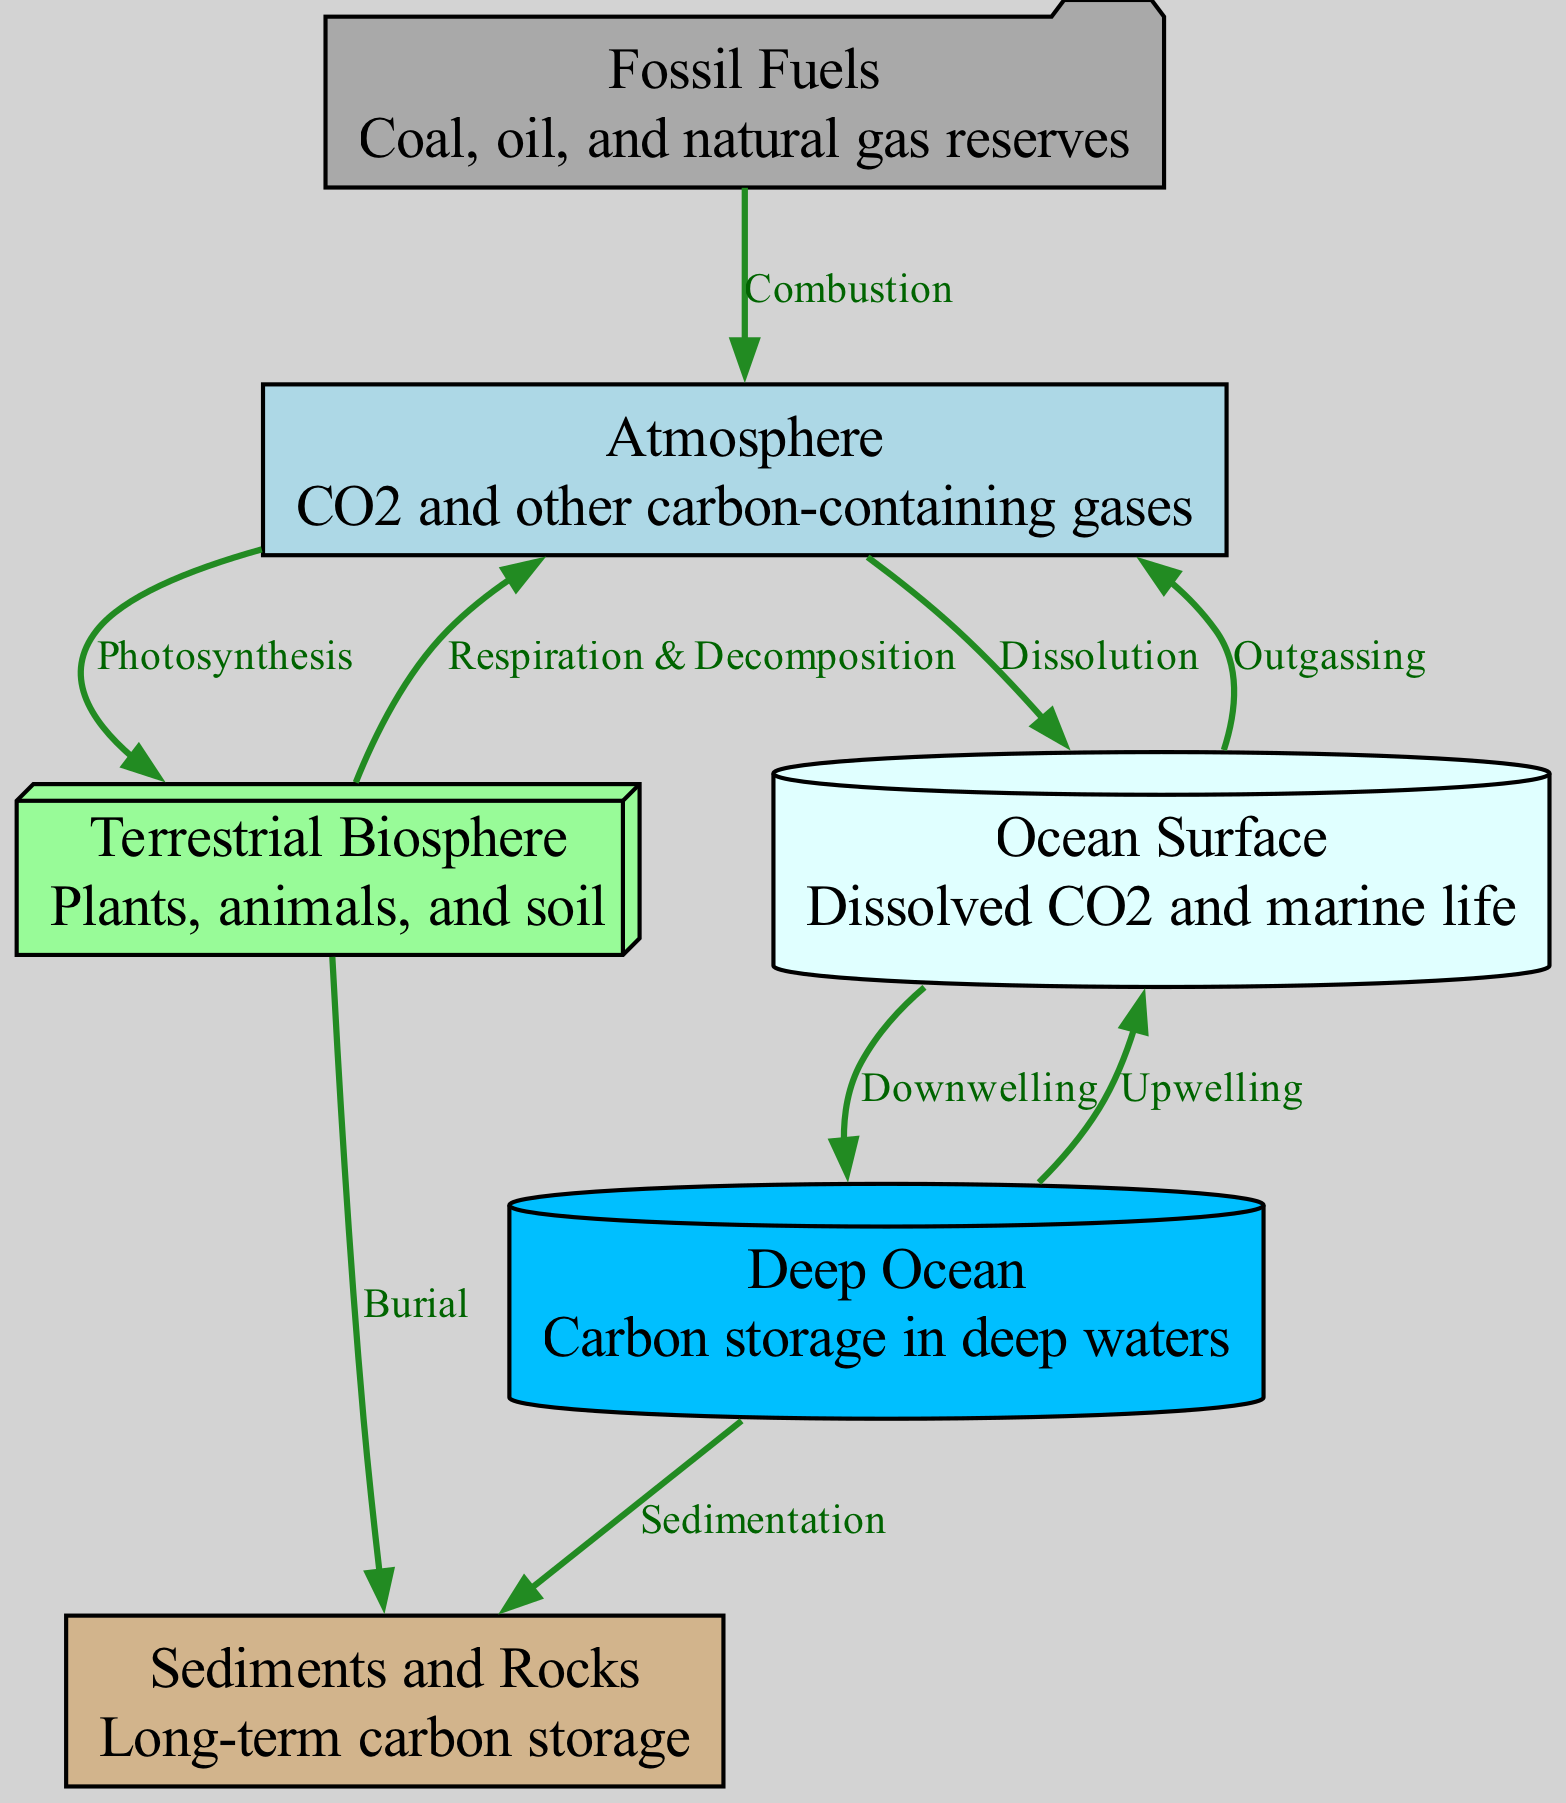What are the components of the carbon cycle illustrated in the diagram? The diagram includes six components: Atmosphere, Terrestrial Biosphere, Ocean Surface, Deep Ocean, Fossil Fuels, and Sediments. These are represented as nodes in the diagram that illustrate where carbon can exist within the cycle.
Answer: Atmosphere, Terrestrial Biosphere, Ocean Surface, Deep Ocean, Fossil Fuels, Sediments How many nodes are present in the diagram? By counting the six distinct nodes represented in the diagram, we can determine that there are a total of six nodes present which correspond to the different components of the carbon cycle.
Answer: 6 What process connects the atmosphere to the terrestrial biosphere? The relevant edge marked "Photosynthesis" indicates the process by which carbon dioxide is absorbed by plants from the atmosphere and used for photosynthesis, thus creating a direct connection between these two nodes.
Answer: Photosynthesis Which node is involved in both respiration and decomposition? The Terrestrial Biosphere node is associated with both processes. The edge labeled "Respiration & Decomposition" connects it back to the atmosphere, highlighting how organisms release carbon through these biological processes.
Answer: Terrestrial Biosphere What connection is established between the ocean surface and the atmosphere? There are two significant edges labeled "Dissolution" and "Outgassing," indicating that carbon is transferred to the ocean surface from the atmosphere via dissolution and returned to the atmosphere from the ocean surface via outgassing.
Answer: Dissolution and Outgassing Which node represents long-term carbon storage? The Sediments and Rocks node is specifically identified for long-term carbon storage. This node emphasizes the geological processes where carbon can be stored over extended periods, separate from the biological cycle.
Answer: Sediments and Rocks What flows from the deep ocean to the sediment node? The process labeled "Sedimentation" represents the flow of carbon from the Deep Ocean to the Sediments node, indicating the geological storage mechanisms where carbon accumulates over time beneath the ocean floor.
Answer: Sedimentation How many edges display a flow from the atmosphere? Three edges lead out from the Atmosphere node, which include "Photosynthesis" to Terrestrial Biosphere, "Dissolution" to Ocean Surface, and "Combustion" to Fossil Fuels, demonstrating multiple pathways by which carbon moves from the atmosphere.
Answer: 3 What is the relationship between the terrestrial biosphere and sediments? The connection is illustrated by the edge labeled "Burial," indicating that organic carbon from the terrestrial biosphere can be buried and eventually transformed into sediment over time, leading to carbon storage in geological contexts.
Answer: Burial 